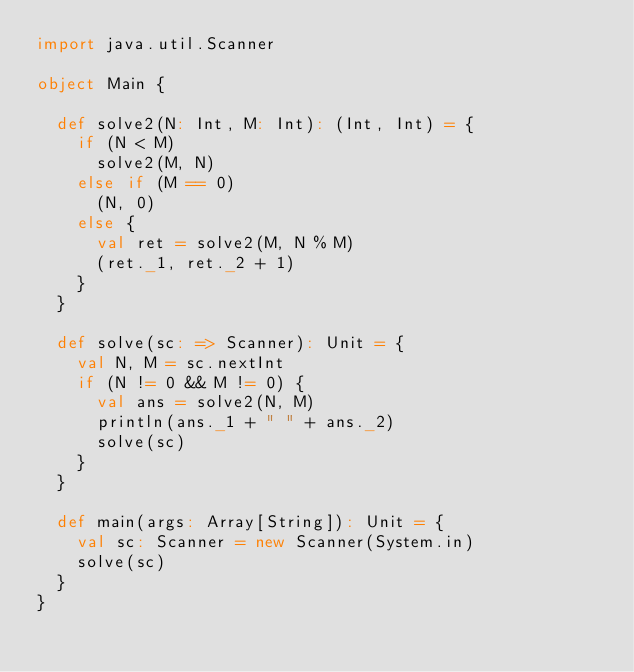<code> <loc_0><loc_0><loc_500><loc_500><_Scala_>import java.util.Scanner

object Main {

  def solve2(N: Int, M: Int): (Int, Int) = {
    if (N < M)
      solve2(M, N)
    else if (M == 0)
      (N, 0)
    else {
      val ret = solve2(M, N % M)
      (ret._1, ret._2 + 1)
    }
  }

  def solve(sc: => Scanner): Unit = {
    val N, M = sc.nextInt
    if (N != 0 && M != 0) {
      val ans = solve2(N, M)
      println(ans._1 + " " + ans._2)
      solve(sc)
    }
  }

  def main(args: Array[String]): Unit = {
    val sc: Scanner = new Scanner(System.in)
    solve(sc)
  }
}</code> 